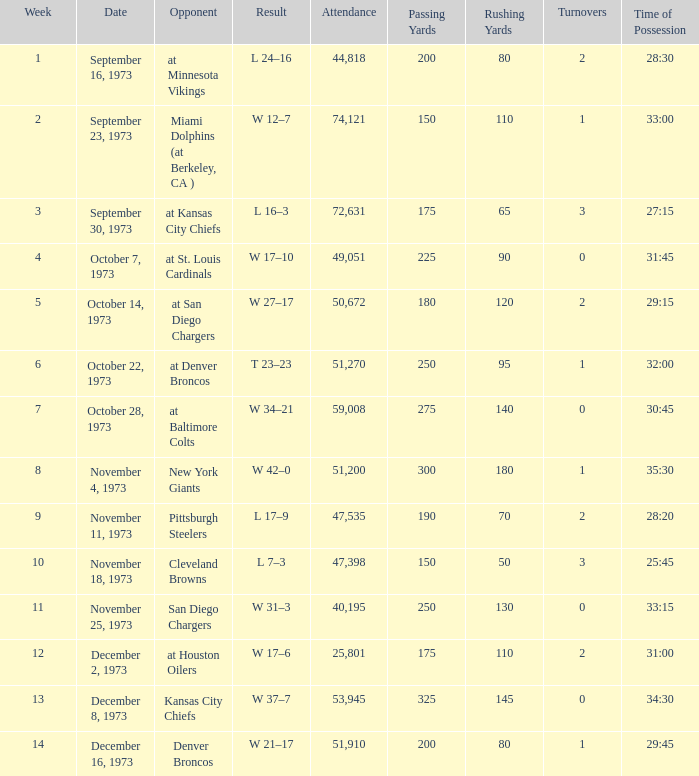What is the highest number in attendance against the game at Kansas City Chiefs? 72631.0. 